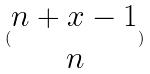<formula> <loc_0><loc_0><loc_500><loc_500>( \begin{matrix} n + x - 1 \\ n \end{matrix} )</formula> 